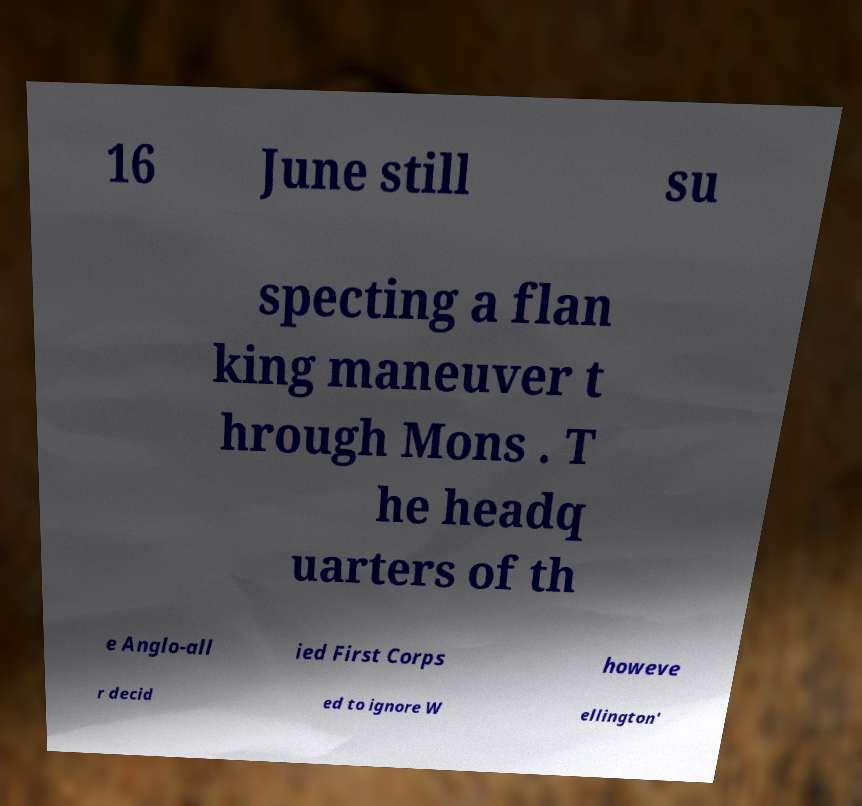For documentation purposes, I need the text within this image transcribed. Could you provide that? 16 June still su specting a flan king maneuver t hrough Mons . T he headq uarters of th e Anglo-all ied First Corps howeve r decid ed to ignore W ellington' 